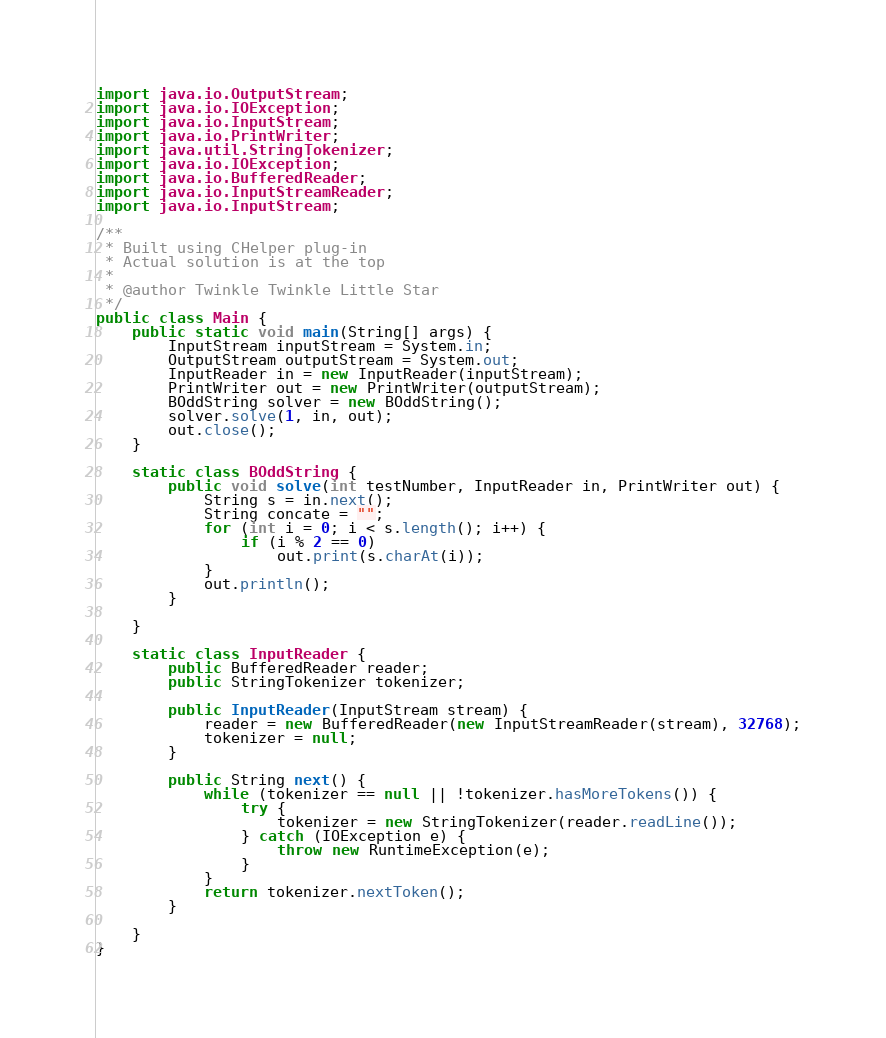<code> <loc_0><loc_0><loc_500><loc_500><_Java_>import java.io.OutputStream;
import java.io.IOException;
import java.io.InputStream;
import java.io.PrintWriter;
import java.util.StringTokenizer;
import java.io.IOException;
import java.io.BufferedReader;
import java.io.InputStreamReader;
import java.io.InputStream;

/**
 * Built using CHelper plug-in
 * Actual solution is at the top
 *
 * @author Twinkle Twinkle Little Star
 */
public class Main {
    public static void main(String[] args) {
        InputStream inputStream = System.in;
        OutputStream outputStream = System.out;
        InputReader in = new InputReader(inputStream);
        PrintWriter out = new PrintWriter(outputStream);
        BOddString solver = new BOddString();
        solver.solve(1, in, out);
        out.close();
    }

    static class BOddString {
        public void solve(int testNumber, InputReader in, PrintWriter out) {
            String s = in.next();
            String concate = "";
            for (int i = 0; i < s.length(); i++) {
                if (i % 2 == 0)
                    out.print(s.charAt(i));
            }
            out.println();
        }

    }

    static class InputReader {
        public BufferedReader reader;
        public StringTokenizer tokenizer;

        public InputReader(InputStream stream) {
            reader = new BufferedReader(new InputStreamReader(stream), 32768);
            tokenizer = null;
        }

        public String next() {
            while (tokenizer == null || !tokenizer.hasMoreTokens()) {
                try {
                    tokenizer = new StringTokenizer(reader.readLine());
                } catch (IOException e) {
                    throw new RuntimeException(e);
                }
            }
            return tokenizer.nextToken();
        }

    }
}

</code> 